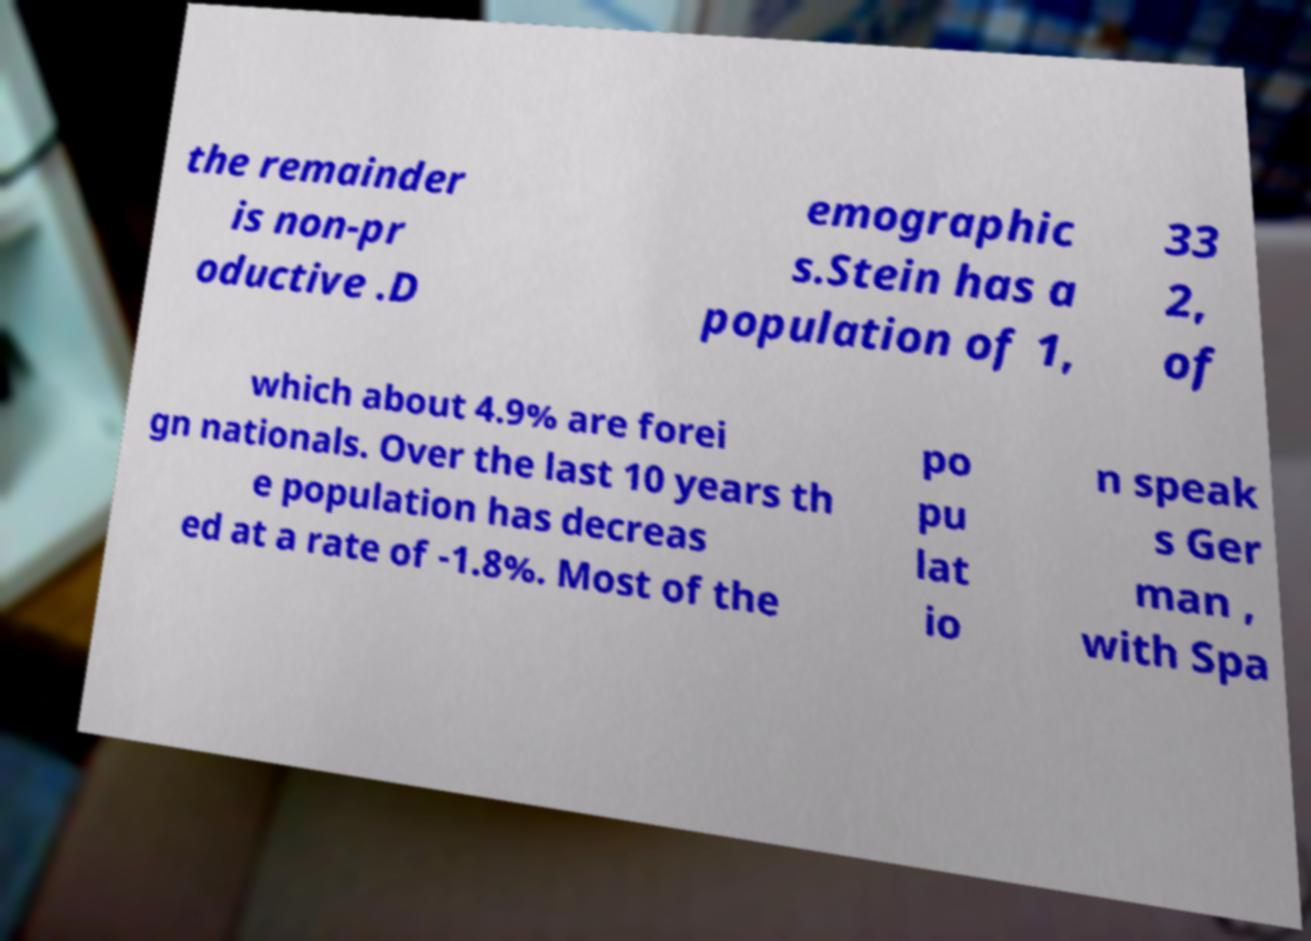Please read and relay the text visible in this image. What does it say? the remainder is non-pr oductive .D emographic s.Stein has a population of 1, 33 2, of which about 4.9% are forei gn nationals. Over the last 10 years th e population has decreas ed at a rate of -1.8%. Most of the po pu lat io n speak s Ger man , with Spa 